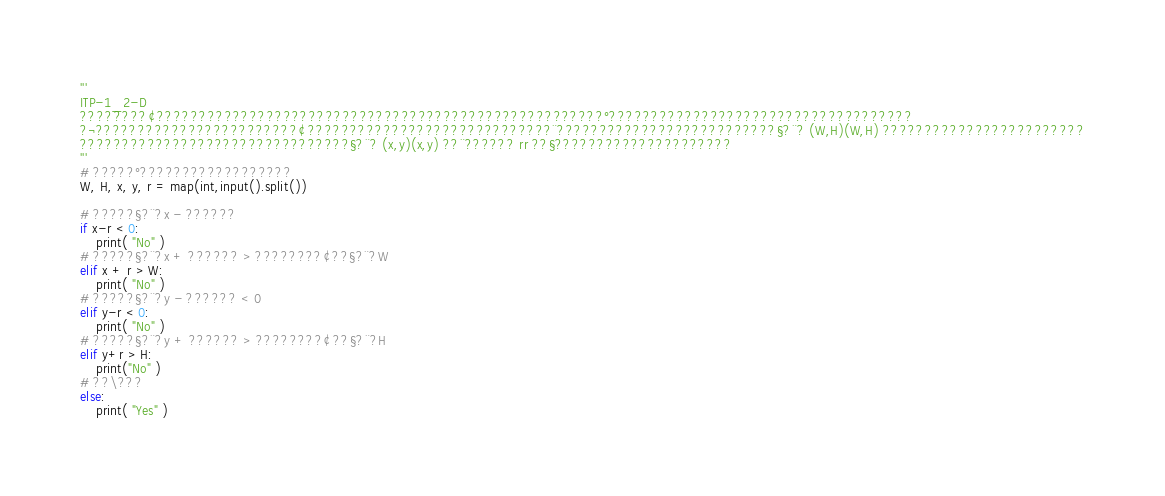Convert code to text. <code><loc_0><loc_0><loc_500><loc_500><_Python_>'''
ITP-1_2-D
????????¢?????????????????????????????????????????????????????°????????????????????????????????????
?¬????????????????????????¢?????????????????????????????¨??????????????????????????§?¨? (W,H)(W,H) ????????????????????????
????????????????????????????????§?¨? (x,y)(x,y) ??¨?????? rr ??§?????????????????????
'''
# ?????°??????????????????
W, H, x, y, r = map(int,input().split())

# ?????§?¨?x - ??????
if x-r < 0:
    print( "No" )
# ?????§?¨?x + ?????? > ????????¢??§?¨?W
elif x + r > W:
    print( "No" )
# ?????§?¨?y - ?????? < 0
elif y-r < 0:
    print( "No" )
# ?????§?¨?y + ?????? > ????????¢??§?¨?H
elif y+r > H:
    print("No" )
# ??\???
else:
    print( "Yes" )</code> 